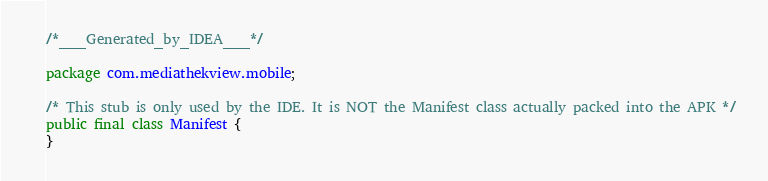Convert code to text. <code><loc_0><loc_0><loc_500><loc_500><_Java_>/*___Generated_by_IDEA___*/

package com.mediathekview.mobile;

/* This stub is only used by the IDE. It is NOT the Manifest class actually packed into the APK */
public final class Manifest {
}</code> 